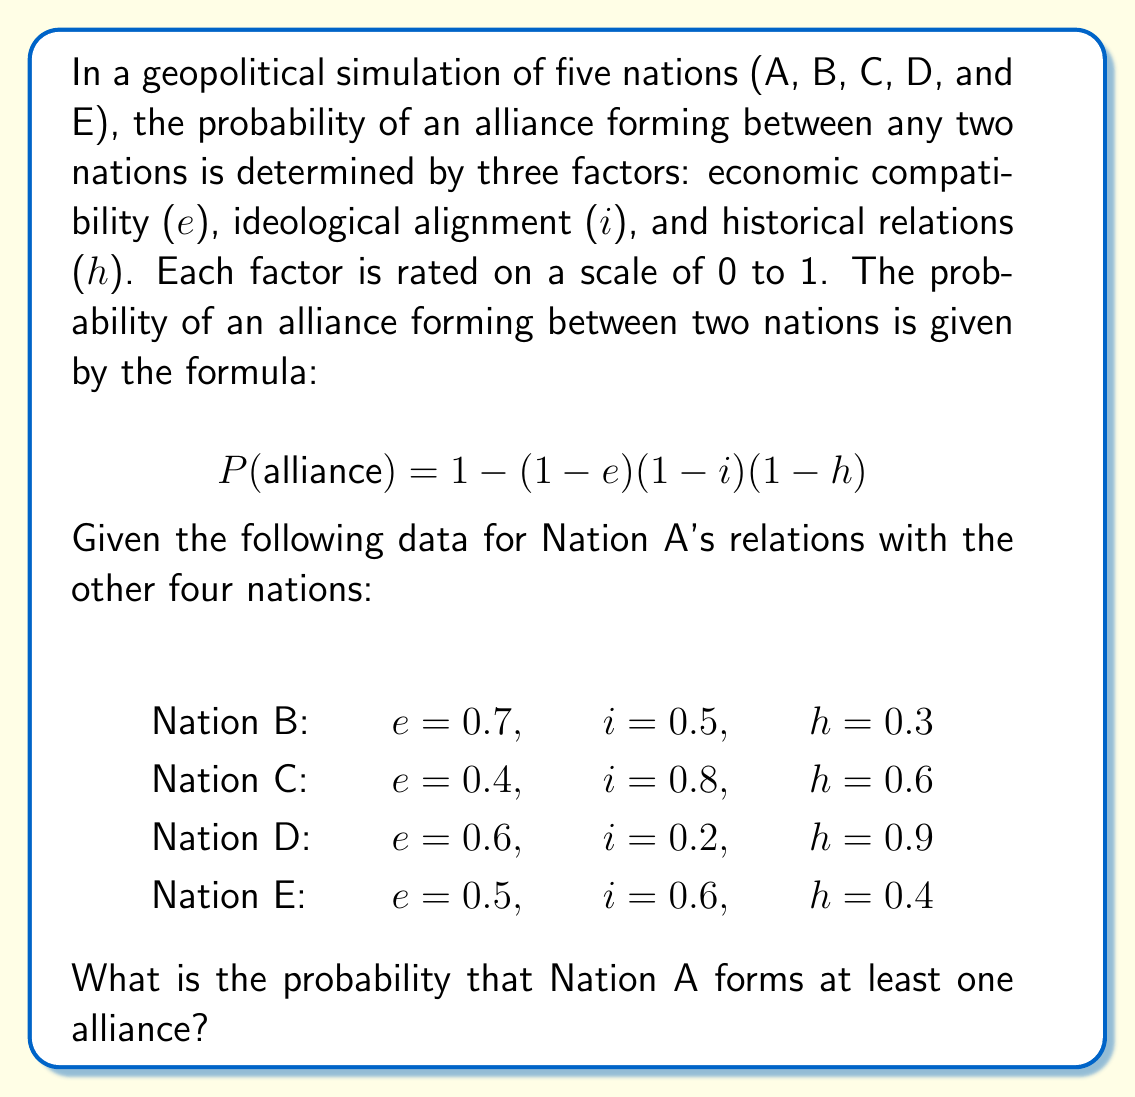Provide a solution to this math problem. To solve this problem, we'll follow these steps:

1. Calculate the probability of an alliance forming between Nation A and each of the other nations.
2. Calculate the probability of Nation A not forming an alliance with each nation.
3. Use the complement rule to find the probability of forming at least one alliance.

Step 1: Calculate alliance probabilities

For Nation B:
$$P(B) = 1 - (1-0.7)(1-0.5)(1-0.3) = 1 - (0.3)(0.5)(0.7) = 1 - 0.105 = 0.895$$

For Nation C:
$$P(C) = 1 - (1-0.4)(1-0.8)(1-0.6) = 1 - (0.6)(0.2)(0.4) = 1 - 0.048 = 0.952$$

For Nation D:
$$P(D) = 1 - (1-0.6)(1-0.2)(1-0.9) = 1 - (0.4)(0.8)(0.1) = 1 - 0.032 = 0.968$$

For Nation E:
$$P(E) = 1 - (1-0.5)(1-0.6)(1-0.4) = 1 - (0.5)(0.4)(0.6) = 1 - 0.12 = 0.88$$

Step 2: Calculate the probability of not forming an alliance with each nation

$$P(\text{no alliance with B}) = 1 - 0.895 = 0.105$$
$$P(\text{no alliance with C}) = 1 - 0.952 = 0.048$$
$$P(\text{no alliance with D}) = 1 - 0.968 = 0.032$$
$$P(\text{no alliance with E}) = 1 - 0.88 = 0.12$$

Step 3: Calculate the probability of forming no alliances

$$P(\text{no alliances}) = 0.105 \times 0.048 \times 0.032 \times 0.12 = 1.935 \times 10^{-5}$$

Step 4: Use the complement rule to find the probability of forming at least one alliance

$$P(\text{at least one alliance}) = 1 - P(\text{no alliances}) = 1 - 1.935 \times 10^{-5} = 0.999980645$$

Therefore, the probability that Nation A forms at least one alliance is approximately 0.999981 or 99.9981%.
Answer: 0.999981 